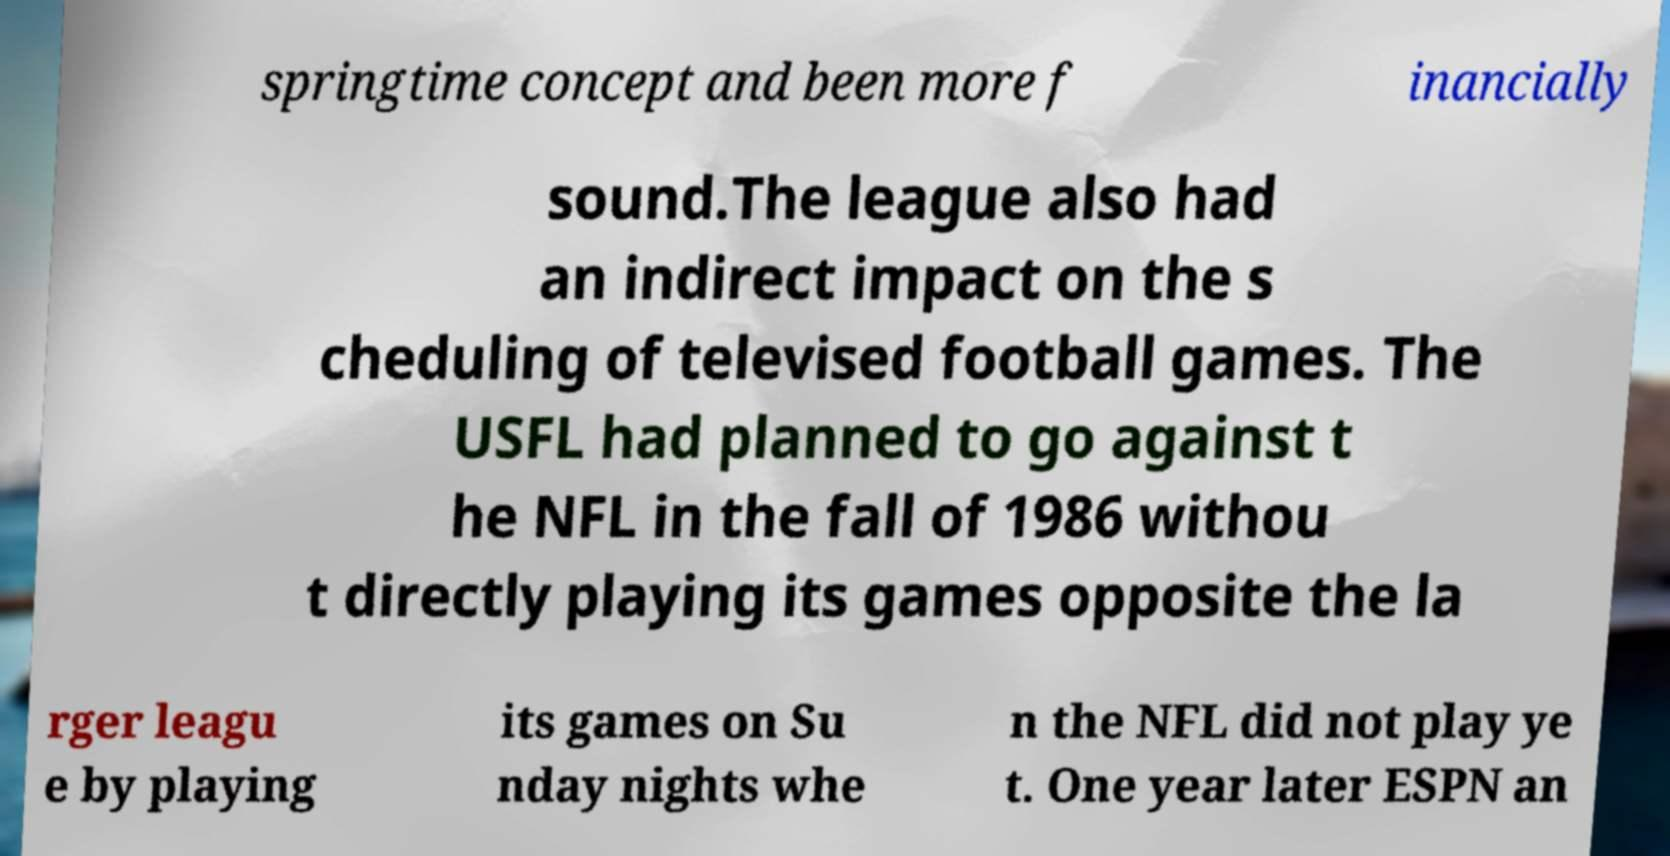What messages or text are displayed in this image? I need them in a readable, typed format. springtime concept and been more f inancially sound.The league also had an indirect impact on the s cheduling of televised football games. The USFL had planned to go against t he NFL in the fall of 1986 withou t directly playing its games opposite the la rger leagu e by playing its games on Su nday nights whe n the NFL did not play ye t. One year later ESPN an 